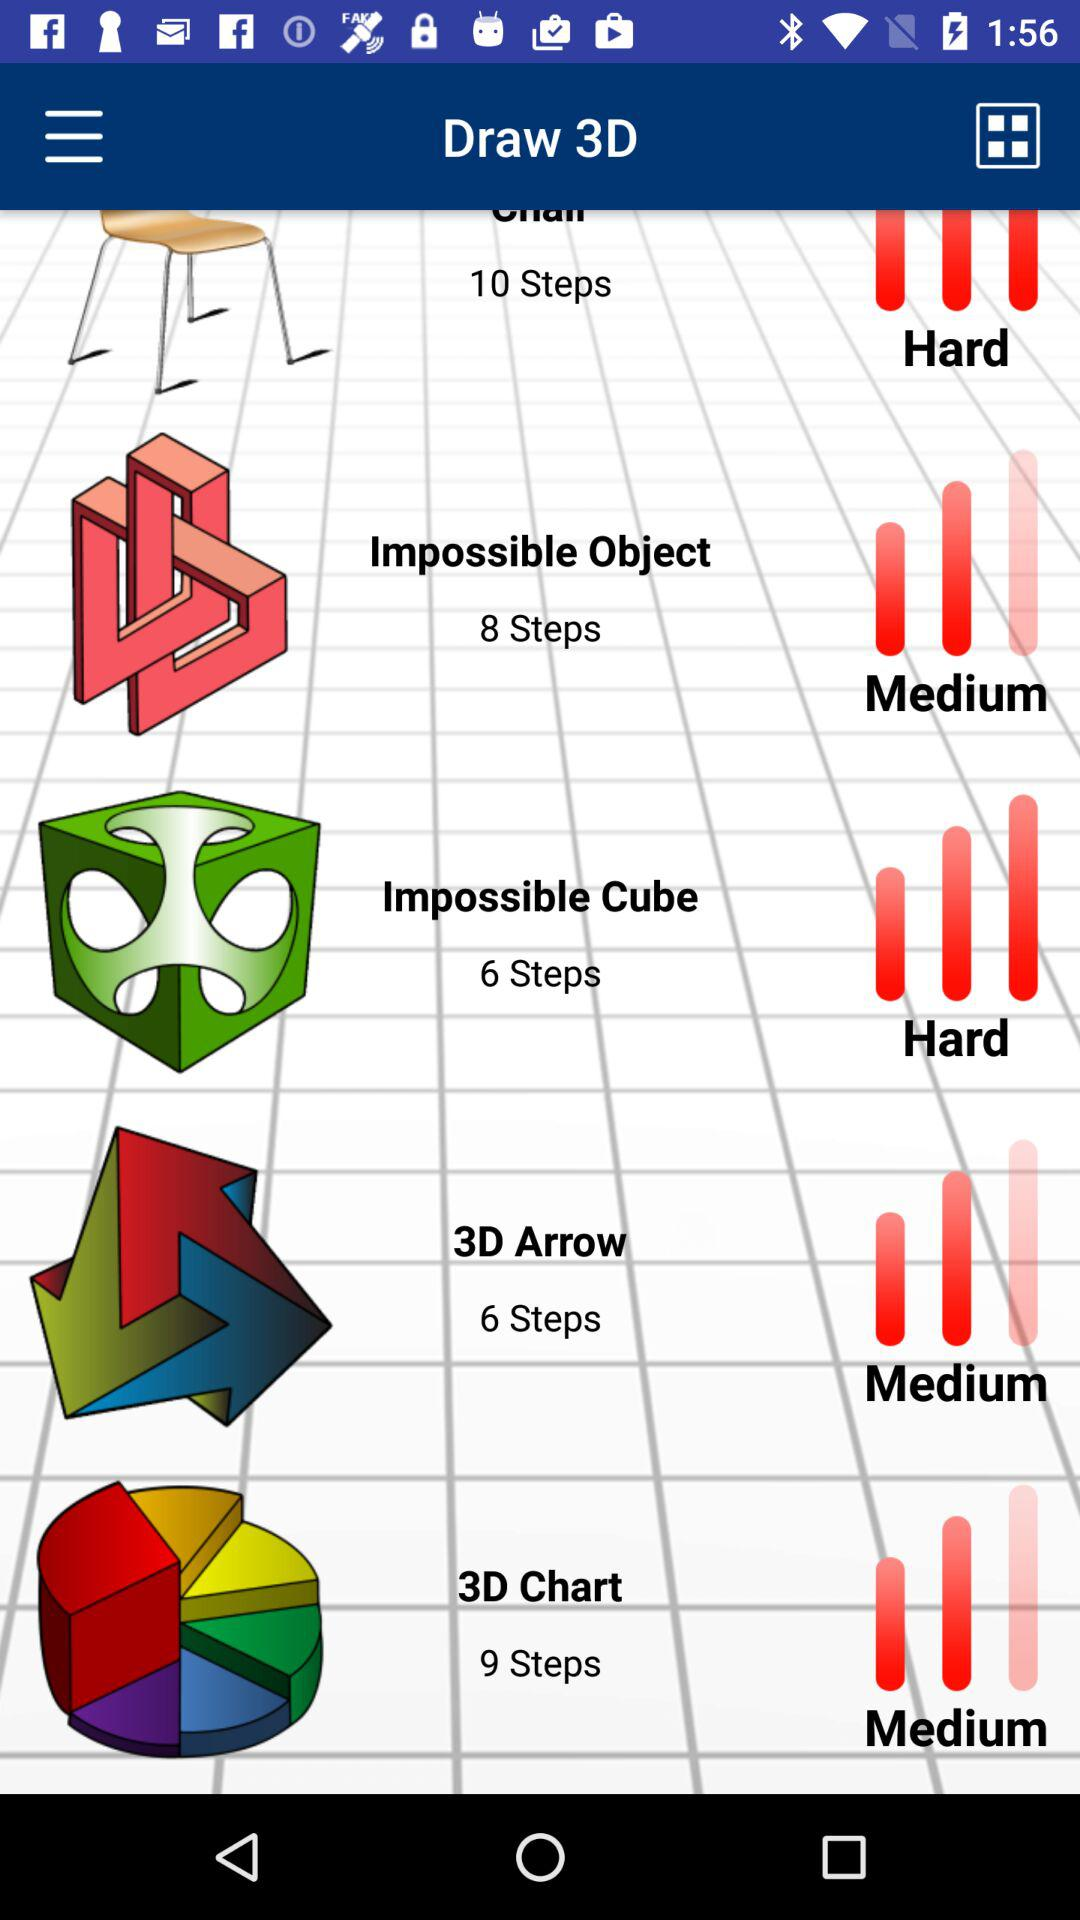What is the difficulty level to draw the "Impossible Cube"? The difficulty level to draw the "Impossible Cube" is hard. 